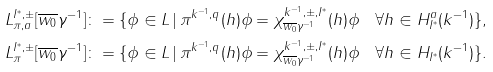<formula> <loc_0><loc_0><loc_500><loc_500>L _ { \pi , a } ^ { I ^ { * } , \pm } [ \overline { w _ { 0 } } \gamma ^ { - 1 } ] & \colon = \{ \phi \in L \, | \, \pi ^ { k ^ { - 1 } , q } ( h ) \phi = \chi _ { \overline { w _ { 0 } } \gamma ^ { - 1 } } ^ { k ^ { - 1 } , \pm , I ^ { * } } ( h ) \phi \quad \forall h \in H _ { I ^ { * } } ^ { a } ( k ^ { - 1 } ) \} , \\ L _ { \pi } ^ { I ^ { * } , \pm } [ \overline { w _ { 0 } } \gamma ^ { - 1 } ] & \colon = \{ \phi \in L \, | \, \pi ^ { k ^ { - 1 } , q } ( h ) \phi = \chi _ { \overline { w _ { 0 } } \gamma ^ { - 1 } } ^ { k ^ { - 1 } , \pm , I ^ { * } } ( h ) \phi \quad \forall h \in H _ { I ^ { * } } ( k ^ { - 1 } ) \} .</formula> 